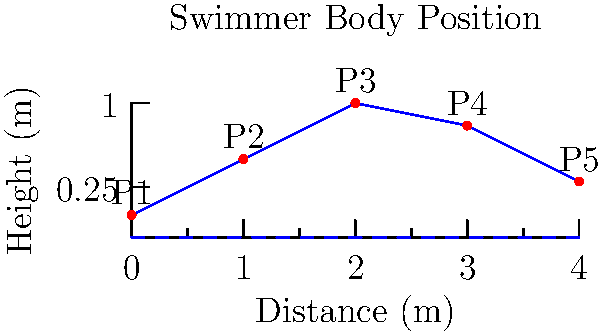In the diagram above, a swimmer's body position is represented by a simplified skeleton model during the freestyle stroke. Points P1 to P5 represent key joints of the swimmer's body. Which point likely represents the swimmer's hip, and how does its position contribute to optimal swimming performance? To answer this question, let's analyze the skeleton model step-by-step:

1. The diagram shows a simplified representation of a swimmer's body during the freestyle stroke.

2. There are 5 points (P1 to P5) representing key joints of the swimmer's body.

3. In freestyle swimming, the body should maintain a streamlined position to reduce drag.

4. The hip is typically the highest point of the body during the freestyle stroke, as it helps maintain body alignment and reduces drag.

5. Looking at the diagram, we can see that P3 is the highest point on the skeleton.

6. The position of P3 (likely the hip) contributes to optimal swimming performance in several ways:
   a) It helps maintain a high body position in the water, reducing frontal drag.
   b) It allows for better rotation of the body during the stroke cycle.
   c) It facilitates a more effective kick by providing a stable core.

7. The slightly lower position of P4 and P5 (likely representing the legs) indicates a good streamlined position, which is crucial for reducing drag and increasing efficiency in the water.

Therefore, P3 is most likely representing the swimmer's hip, and its elevated position contributes to optimal swimming performance by reducing drag and improving body alignment.
Answer: P3; elevated position reduces drag and improves body alignment 